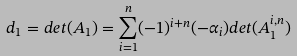Convert formula to latex. <formula><loc_0><loc_0><loc_500><loc_500>d _ { 1 } = d e t ( A _ { 1 } ) = \sum _ { i = 1 } ^ { n } ( - 1 ) ^ { i + n } ( - \alpha _ { i } ) d e t ( A _ { 1 } ^ { i , n } )</formula> 